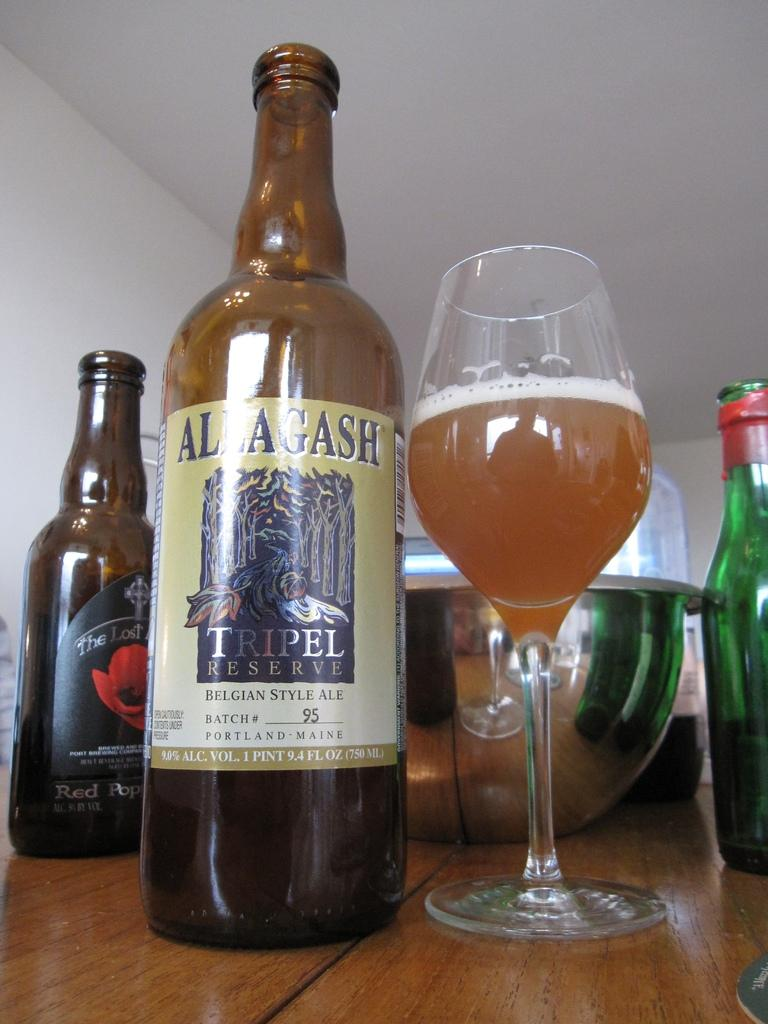<image>
Share a concise interpretation of the image provided. Beer bottle for Allagash on top of a table and next to a glass of beer. 